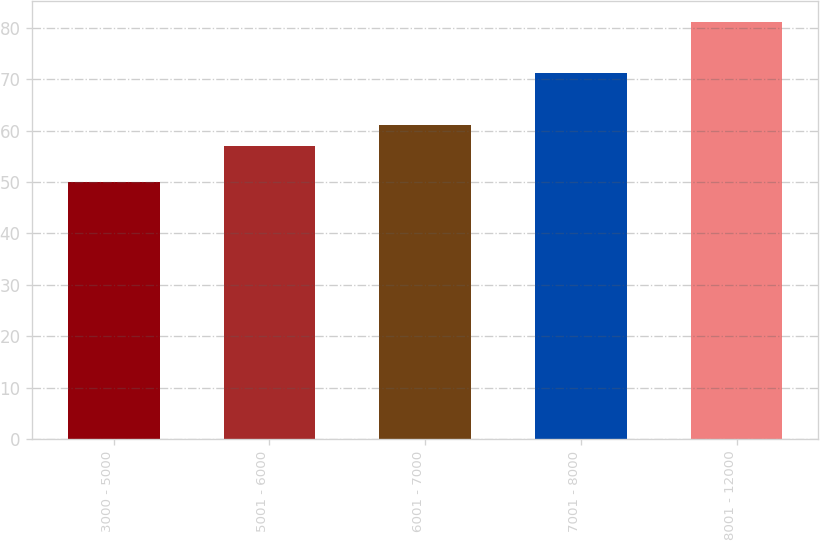Convert chart. <chart><loc_0><loc_0><loc_500><loc_500><bar_chart><fcel>3000 - 5000<fcel>5001 - 6000<fcel>6001 - 7000<fcel>7001 - 8000<fcel>8001 - 12000<nl><fcel>49.95<fcel>56.97<fcel>61.17<fcel>71.22<fcel>81.11<nl></chart> 